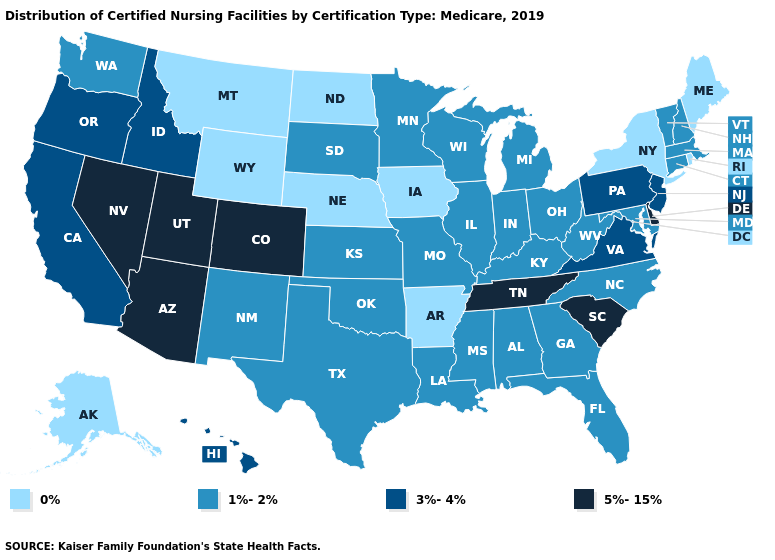What is the value of Vermont?
Give a very brief answer. 1%-2%. What is the value of Maine?
Be succinct. 0%. Name the states that have a value in the range 5%-15%?
Short answer required. Arizona, Colorado, Delaware, Nevada, South Carolina, Tennessee, Utah. What is the highest value in states that border South Dakota?
Write a very short answer. 1%-2%. Name the states that have a value in the range 5%-15%?
Write a very short answer. Arizona, Colorado, Delaware, Nevada, South Carolina, Tennessee, Utah. Which states hav the highest value in the West?
Answer briefly. Arizona, Colorado, Nevada, Utah. What is the value of West Virginia?
Short answer required. 1%-2%. Among the states that border Alabama , does Tennessee have the highest value?
Short answer required. Yes. Name the states that have a value in the range 3%-4%?
Answer briefly. California, Hawaii, Idaho, New Jersey, Oregon, Pennsylvania, Virginia. What is the value of North Carolina?
Quick response, please. 1%-2%. Name the states that have a value in the range 1%-2%?
Write a very short answer. Alabama, Connecticut, Florida, Georgia, Illinois, Indiana, Kansas, Kentucky, Louisiana, Maryland, Massachusetts, Michigan, Minnesota, Mississippi, Missouri, New Hampshire, New Mexico, North Carolina, Ohio, Oklahoma, South Dakota, Texas, Vermont, Washington, West Virginia, Wisconsin. Does California have a higher value than Kansas?
Concise answer only. Yes. Name the states that have a value in the range 3%-4%?
Give a very brief answer. California, Hawaii, Idaho, New Jersey, Oregon, Pennsylvania, Virginia. What is the value of Louisiana?
Write a very short answer. 1%-2%. What is the value of Idaho?
Quick response, please. 3%-4%. 